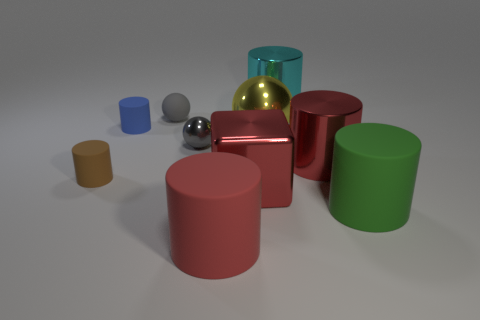Describe the lighting and shadows in the image, and what do they suggest about the setting? The image has a soft, diffused lighting with shadows falling to the right of the objects, suggesting an overhead light source slightly to the left. The effect is a calm, controlled environment, likely indoors, with no direct harsh light. It gives the scene a studio-like setting, focusing attention on the objects and their materials. 